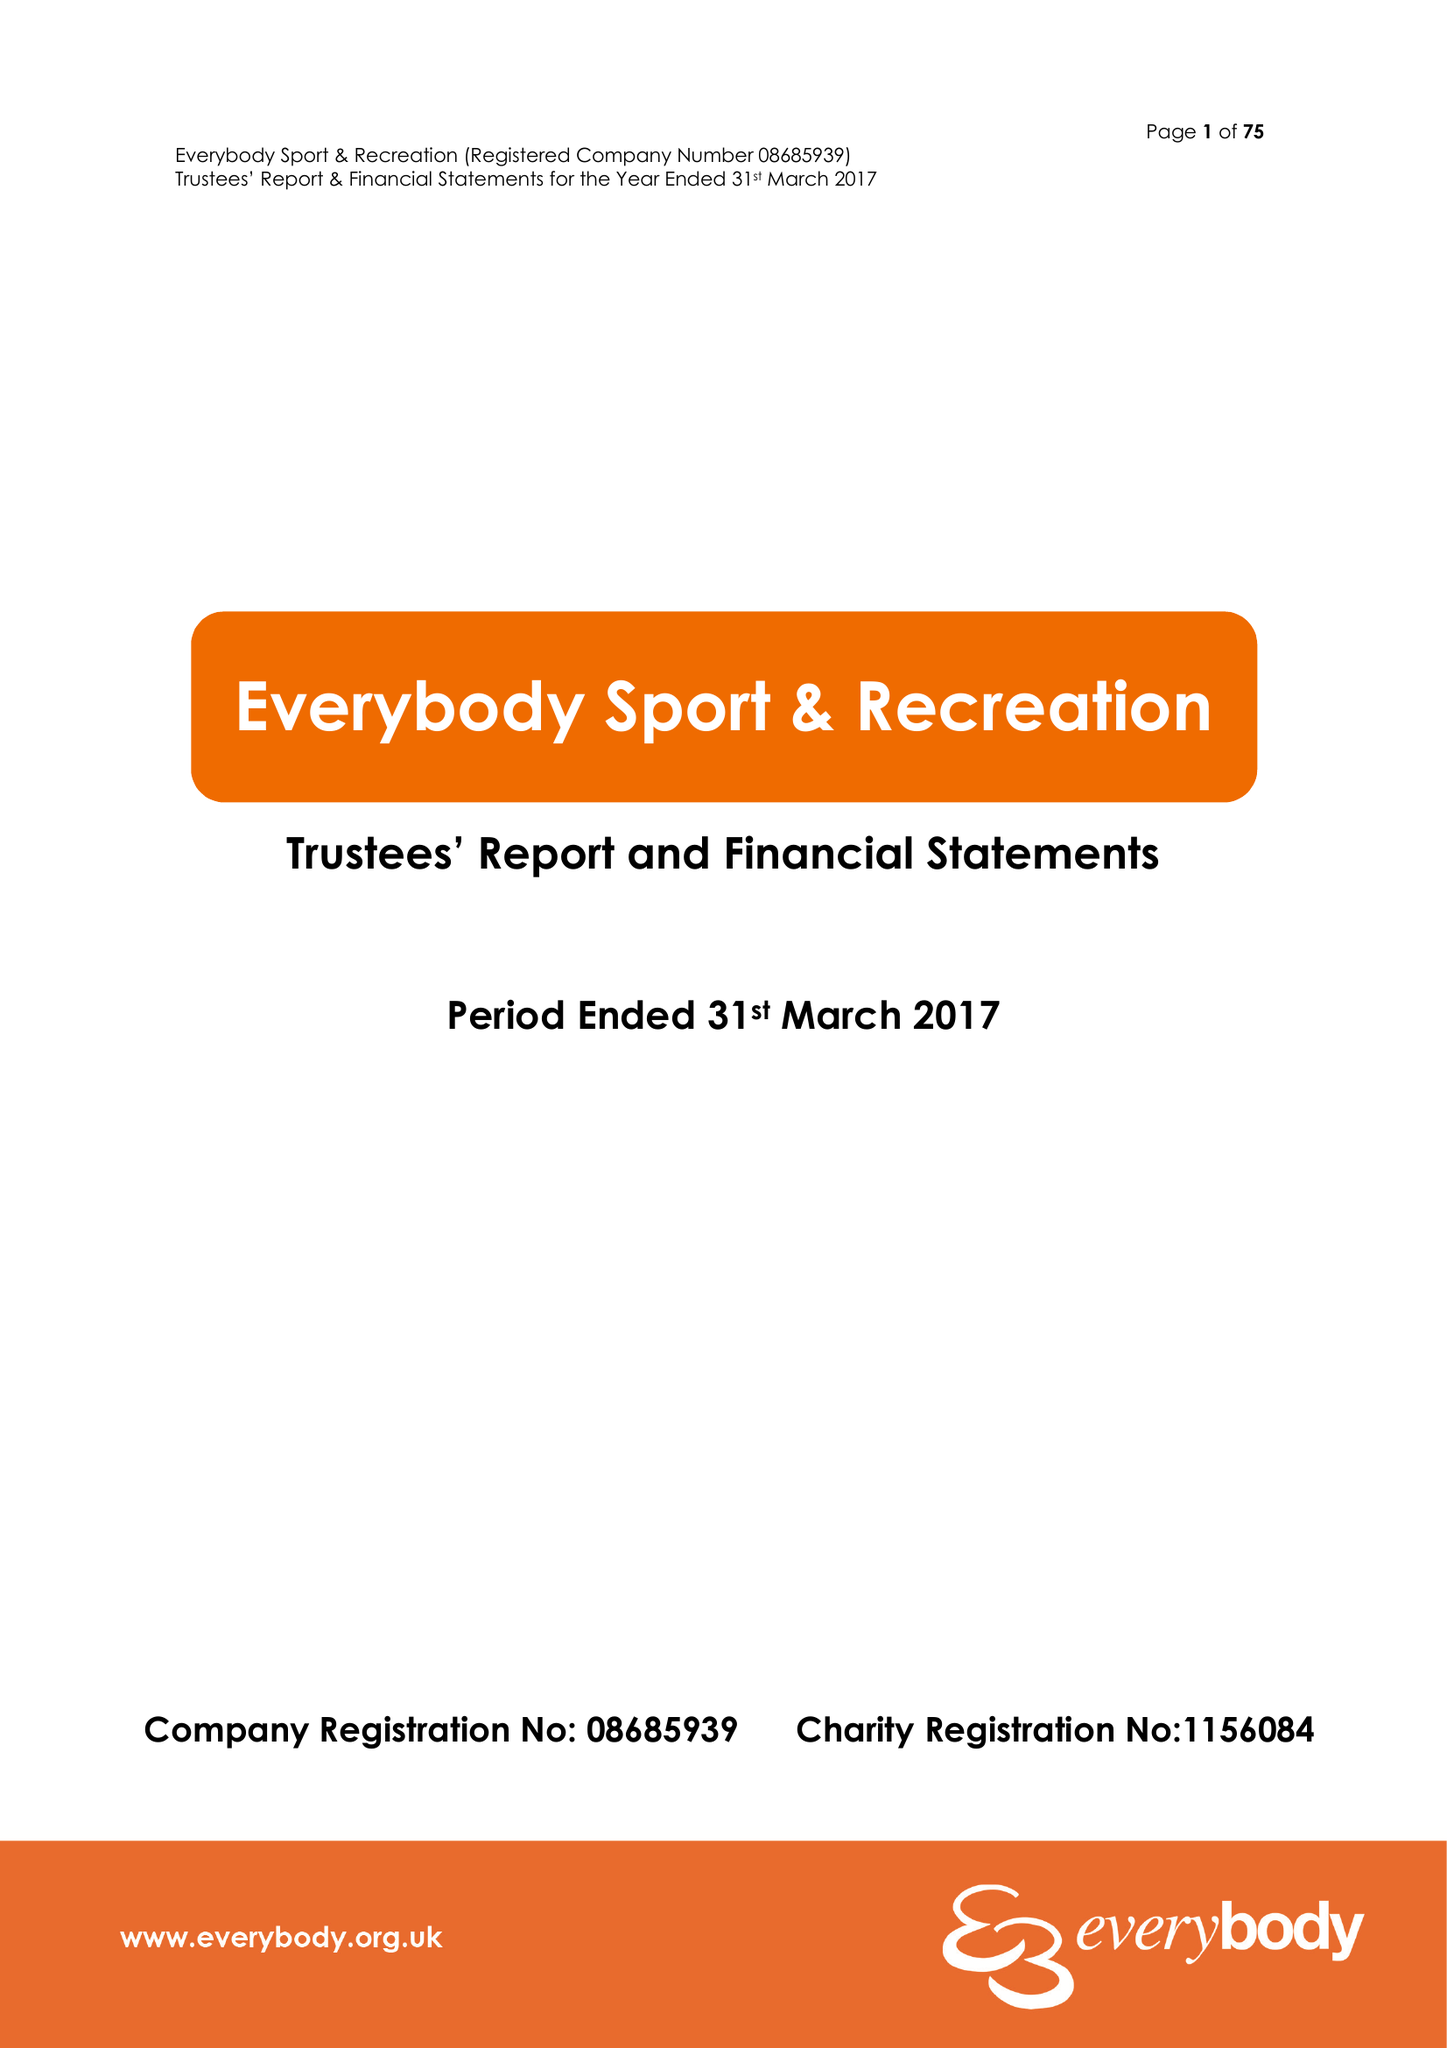What is the value for the charity_number?
Answer the question using a single word or phrase. 1156084 